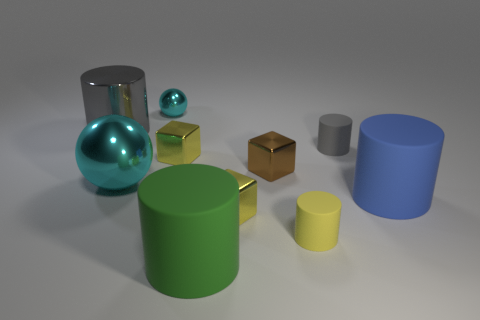Subtract all big gray cylinders. How many cylinders are left? 4 Subtract all brown cylinders. Subtract all yellow cubes. How many cylinders are left? 5 Subtract all spheres. How many objects are left? 8 Add 3 big blue rubber cylinders. How many big blue rubber cylinders are left? 4 Add 3 blue matte objects. How many blue matte objects exist? 4 Subtract 0 red cylinders. How many objects are left? 10 Subtract all big shiny things. Subtract all big things. How many objects are left? 4 